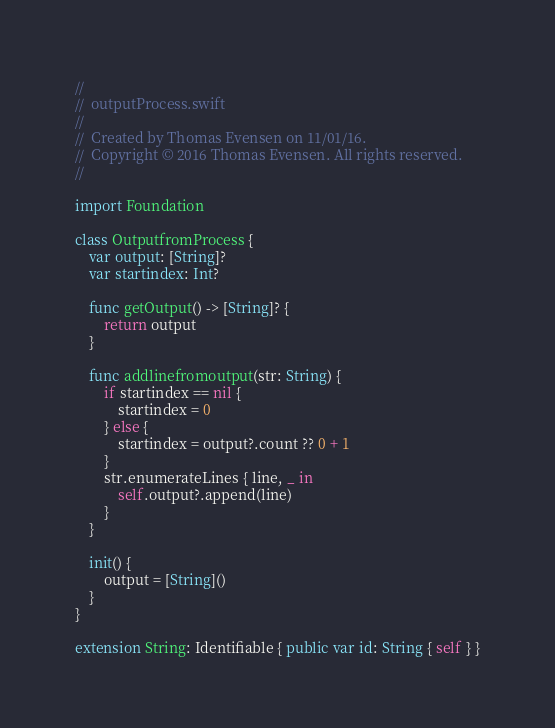<code> <loc_0><loc_0><loc_500><loc_500><_Swift_>//
//  outputProcess.swift
//
//  Created by Thomas Evensen on 11/01/16.
//  Copyright © 2016 Thomas Evensen. All rights reserved.
//

import Foundation

class OutputfromProcess {
    var output: [String]?
    var startindex: Int?

    func getOutput() -> [String]? {
        return output
    }

    func addlinefromoutput(str: String) {
        if startindex == nil {
            startindex = 0
        } else {
            startindex = output?.count ?? 0 + 1
        }
        str.enumerateLines { line, _ in
            self.output?.append(line)
        }
    }

    init() {
        output = [String]()
    }
}

extension String: Identifiable { public var id: String { self } }
</code> 